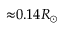Convert formula to latex. <formula><loc_0><loc_0><loc_500><loc_500>{ \approx } 0 . 1 4 R _ { \odot }</formula> 